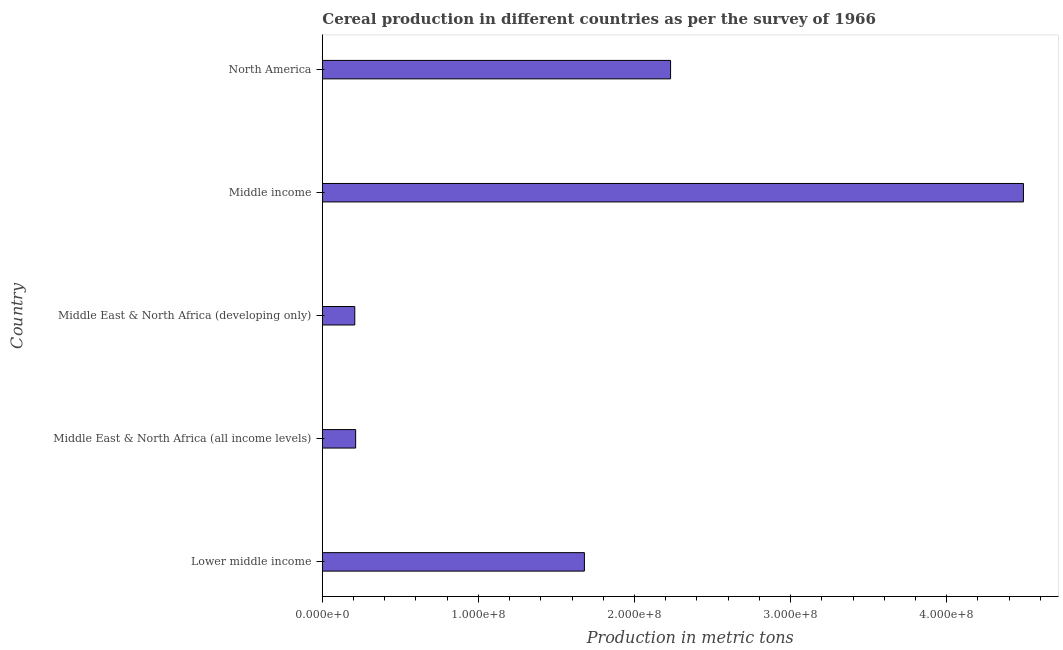Does the graph contain grids?
Ensure brevity in your answer.  No. What is the title of the graph?
Make the answer very short. Cereal production in different countries as per the survey of 1966. What is the label or title of the X-axis?
Your response must be concise. Production in metric tons. What is the cereal production in Middle East & North Africa (all income levels)?
Ensure brevity in your answer.  2.14e+07. Across all countries, what is the maximum cereal production?
Your response must be concise. 4.49e+08. Across all countries, what is the minimum cereal production?
Give a very brief answer. 2.08e+07. In which country was the cereal production maximum?
Offer a very short reply. Middle income. In which country was the cereal production minimum?
Your answer should be compact. Middle East & North Africa (developing only). What is the sum of the cereal production?
Keep it short and to the point. 8.82e+08. What is the difference between the cereal production in Lower middle income and Middle income?
Offer a terse response. -2.81e+08. What is the average cereal production per country?
Provide a succinct answer. 1.76e+08. What is the median cereal production?
Ensure brevity in your answer.  1.68e+08. What is the ratio of the cereal production in Middle East & North Africa (developing only) to that in Middle income?
Your answer should be very brief. 0.05. What is the difference between the highest and the second highest cereal production?
Ensure brevity in your answer.  2.26e+08. Is the sum of the cereal production in Lower middle income and Middle East & North Africa (all income levels) greater than the maximum cereal production across all countries?
Give a very brief answer. No. What is the difference between the highest and the lowest cereal production?
Give a very brief answer. 4.28e+08. In how many countries, is the cereal production greater than the average cereal production taken over all countries?
Your response must be concise. 2. Are the values on the major ticks of X-axis written in scientific E-notation?
Offer a terse response. Yes. What is the Production in metric tons in Lower middle income?
Your answer should be compact. 1.68e+08. What is the Production in metric tons of Middle East & North Africa (all income levels)?
Your answer should be very brief. 2.14e+07. What is the Production in metric tons of Middle East & North Africa (developing only)?
Your response must be concise. 2.08e+07. What is the Production in metric tons in Middle income?
Give a very brief answer. 4.49e+08. What is the Production in metric tons of North America?
Offer a very short reply. 2.23e+08. What is the difference between the Production in metric tons in Lower middle income and Middle East & North Africa (all income levels)?
Provide a short and direct response. 1.47e+08. What is the difference between the Production in metric tons in Lower middle income and Middle East & North Africa (developing only)?
Provide a succinct answer. 1.47e+08. What is the difference between the Production in metric tons in Lower middle income and Middle income?
Offer a very short reply. -2.81e+08. What is the difference between the Production in metric tons in Lower middle income and North America?
Your answer should be very brief. -5.52e+07. What is the difference between the Production in metric tons in Middle East & North Africa (all income levels) and Middle East & North Africa (developing only)?
Ensure brevity in your answer.  5.70e+05. What is the difference between the Production in metric tons in Middle East & North Africa (all income levels) and Middle income?
Offer a terse response. -4.28e+08. What is the difference between the Production in metric tons in Middle East & North Africa (all income levels) and North America?
Give a very brief answer. -2.02e+08. What is the difference between the Production in metric tons in Middle East & North Africa (developing only) and Middle income?
Your response must be concise. -4.28e+08. What is the difference between the Production in metric tons in Middle East & North Africa (developing only) and North America?
Provide a succinct answer. -2.02e+08. What is the difference between the Production in metric tons in Middle income and North America?
Your answer should be very brief. 2.26e+08. What is the ratio of the Production in metric tons in Lower middle income to that in Middle East & North Africa (all income levels)?
Your response must be concise. 7.86. What is the ratio of the Production in metric tons in Lower middle income to that in Middle East & North Africa (developing only)?
Provide a succinct answer. 8.08. What is the ratio of the Production in metric tons in Lower middle income to that in Middle income?
Make the answer very short. 0.37. What is the ratio of the Production in metric tons in Lower middle income to that in North America?
Offer a very short reply. 0.75. What is the ratio of the Production in metric tons in Middle East & North Africa (all income levels) to that in Middle income?
Offer a very short reply. 0.05. What is the ratio of the Production in metric tons in Middle East & North Africa (all income levels) to that in North America?
Make the answer very short. 0.1. What is the ratio of the Production in metric tons in Middle East & North Africa (developing only) to that in Middle income?
Provide a succinct answer. 0.05. What is the ratio of the Production in metric tons in Middle East & North Africa (developing only) to that in North America?
Ensure brevity in your answer.  0.09. What is the ratio of the Production in metric tons in Middle income to that in North America?
Provide a succinct answer. 2.01. 